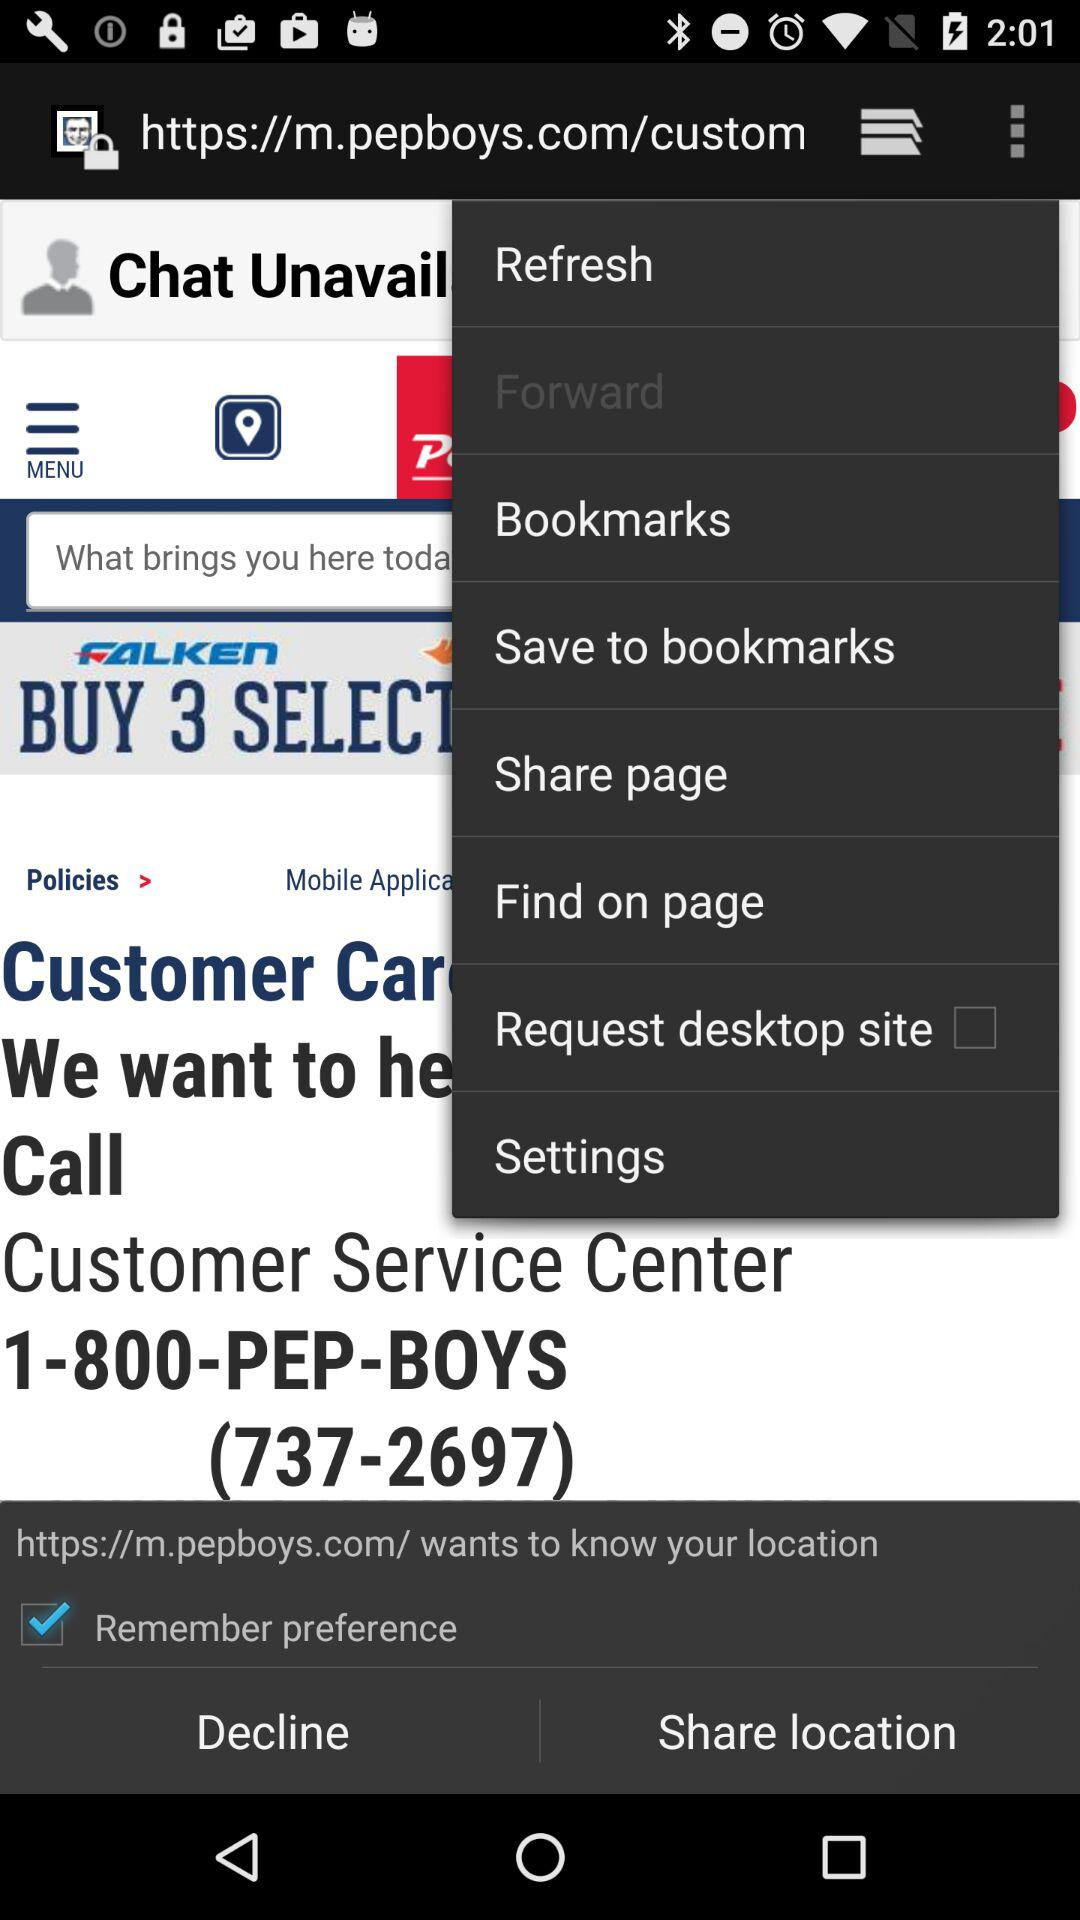What is the number of the customer service center? The number of the customer service center is 1-800-PEP-BOYS (737-2697). 